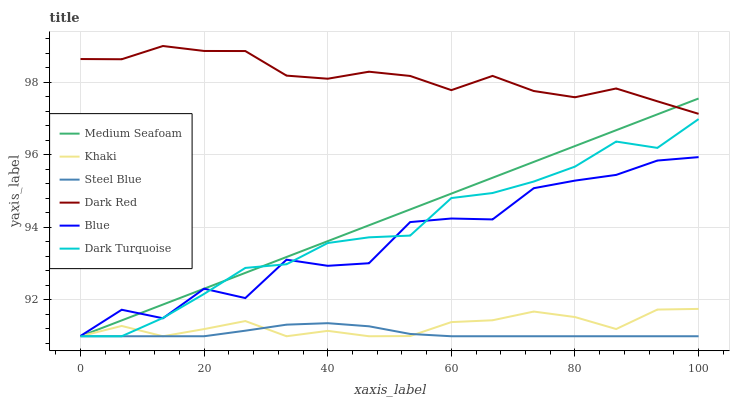Does Steel Blue have the minimum area under the curve?
Answer yes or no. Yes. Does Dark Red have the maximum area under the curve?
Answer yes or no. Yes. Does Khaki have the minimum area under the curve?
Answer yes or no. No. Does Khaki have the maximum area under the curve?
Answer yes or no. No. Is Medium Seafoam the smoothest?
Answer yes or no. Yes. Is Blue the roughest?
Answer yes or no. Yes. Is Khaki the smoothest?
Answer yes or no. No. Is Khaki the roughest?
Answer yes or no. No. Does Dark Red have the lowest value?
Answer yes or no. No. Does Khaki have the highest value?
Answer yes or no. No. Is Khaki less than Blue?
Answer yes or no. Yes. Is Dark Red greater than Dark Turquoise?
Answer yes or no. Yes. Does Khaki intersect Blue?
Answer yes or no. No. 